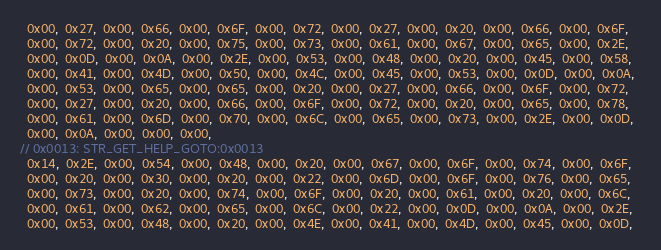<code> <loc_0><loc_0><loc_500><loc_500><_C_>  0x00,  0x27,  0x00,  0x66,  0x00,  0x6F,  0x00,  0x72,  0x00,  0x27,  0x00,  0x20,  0x00,  0x66,  0x00,  0x6F,  
  0x00,  0x72,  0x00,  0x20,  0x00,  0x75,  0x00,  0x73,  0x00,  0x61,  0x00,  0x67,  0x00,  0x65,  0x00,  0x2E,  
  0x00,  0x0D,  0x00,  0x0A,  0x00,  0x2E,  0x00,  0x53,  0x00,  0x48,  0x00,  0x20,  0x00,  0x45,  0x00,  0x58,  
  0x00,  0x41,  0x00,  0x4D,  0x00,  0x50,  0x00,  0x4C,  0x00,  0x45,  0x00,  0x53,  0x00,  0x0D,  0x00,  0x0A,  
  0x00,  0x53,  0x00,  0x65,  0x00,  0x65,  0x00,  0x20,  0x00,  0x27,  0x00,  0x66,  0x00,  0x6F,  0x00,  0x72,  
  0x00,  0x27,  0x00,  0x20,  0x00,  0x66,  0x00,  0x6F,  0x00,  0x72,  0x00,  0x20,  0x00,  0x65,  0x00,  0x78,  
  0x00,  0x61,  0x00,  0x6D,  0x00,  0x70,  0x00,  0x6C,  0x00,  0x65,  0x00,  0x73,  0x00,  0x2E,  0x00,  0x0D,  
  0x00,  0x0A,  0x00,  0x00,  0x00,
// 0x0013: STR_GET_HELP_GOTO:0x0013
  0x14,  0x2E,  0x00,  0x54,  0x00,  0x48,  0x00,  0x20,  0x00,  0x67,  0x00,  0x6F,  0x00,  0x74,  0x00,  0x6F,  
  0x00,  0x20,  0x00,  0x30,  0x00,  0x20,  0x00,  0x22,  0x00,  0x6D,  0x00,  0x6F,  0x00,  0x76,  0x00,  0x65,  
  0x00,  0x73,  0x00,  0x20,  0x00,  0x74,  0x00,  0x6F,  0x00,  0x20,  0x00,  0x61,  0x00,  0x20,  0x00,  0x6C,  
  0x00,  0x61,  0x00,  0x62,  0x00,  0x65,  0x00,  0x6C,  0x00,  0x22,  0x00,  0x0D,  0x00,  0x0A,  0x00,  0x2E,  
  0x00,  0x53,  0x00,  0x48,  0x00,  0x20,  0x00,  0x4E,  0x00,  0x41,  0x00,  0x4D,  0x00,  0x45,  0x00,  0x0D,  </code> 